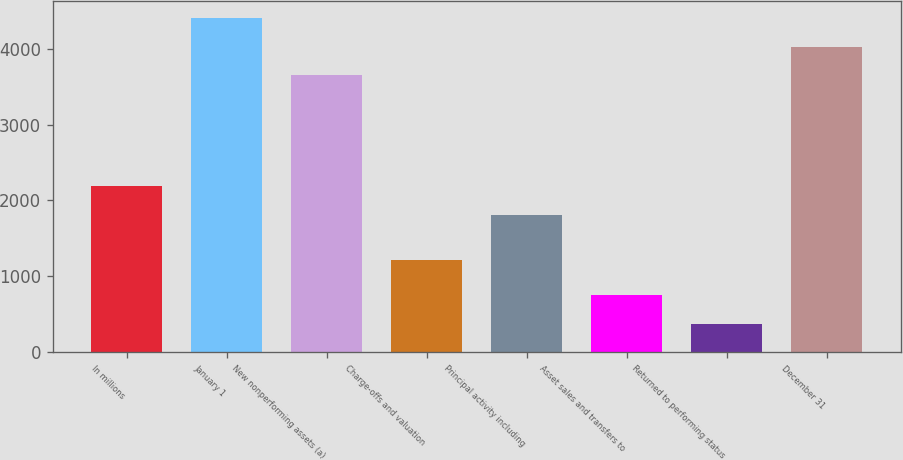Convert chart to OTSL. <chart><loc_0><loc_0><loc_500><loc_500><bar_chart><fcel>In millions<fcel>January 1<fcel>New nonperforming assets (a)<fcel>Charge-offs and valuation<fcel>Principal activity including<fcel>Asset sales and transfers to<fcel>Returned to performing status<fcel>December 31<nl><fcel>2190.6<fcel>4405.2<fcel>3648<fcel>1218<fcel>1812<fcel>748.6<fcel>370<fcel>4026.6<nl></chart> 